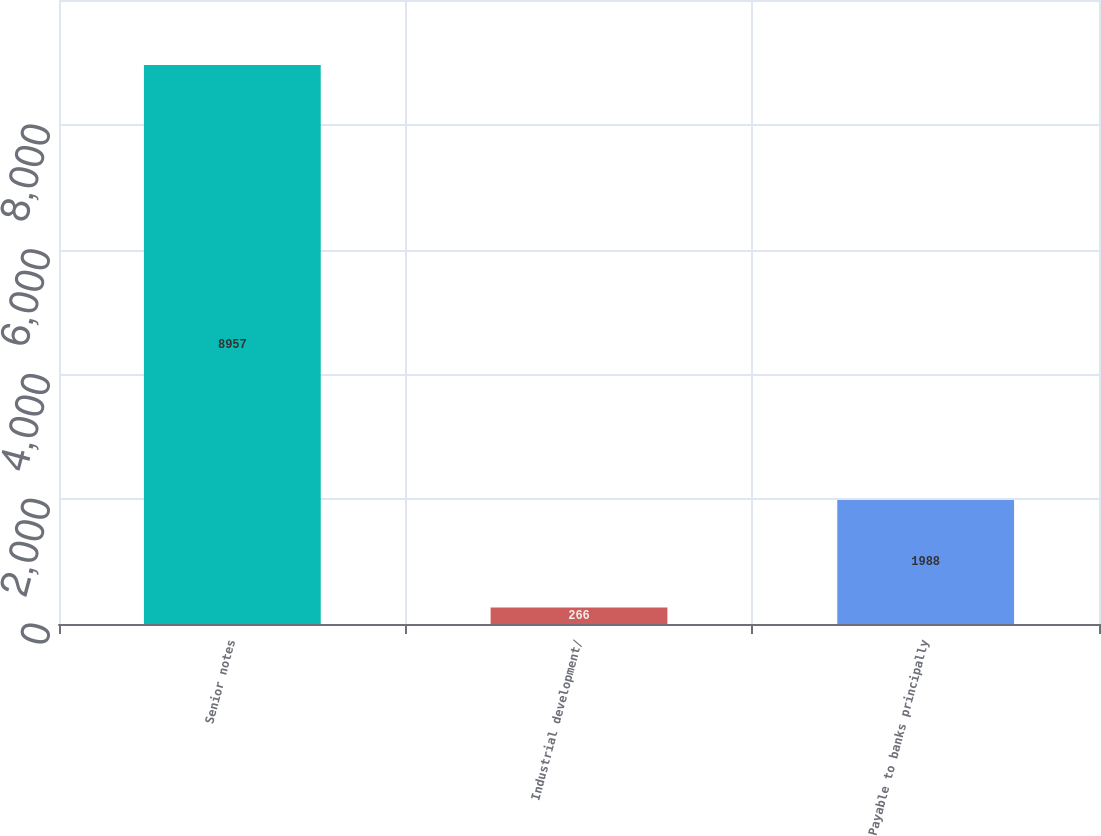Convert chart to OTSL. <chart><loc_0><loc_0><loc_500><loc_500><bar_chart><fcel>Senior notes<fcel>Industrial development/<fcel>Payable to banks principally<nl><fcel>8957<fcel>266<fcel>1988<nl></chart> 